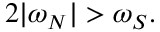<formula> <loc_0><loc_0><loc_500><loc_500>2 | \omega _ { N } | > \omega _ { S } .</formula> 